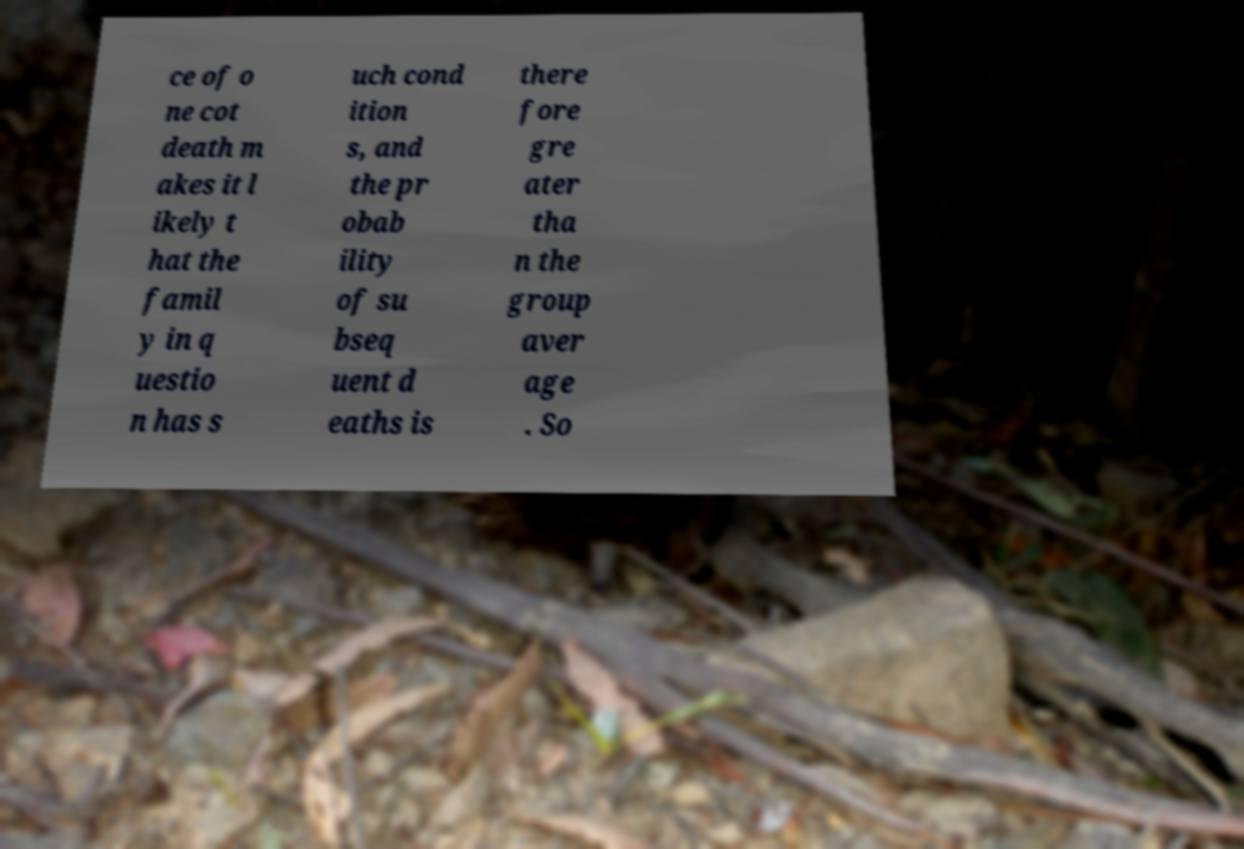There's text embedded in this image that I need extracted. Can you transcribe it verbatim? ce of o ne cot death m akes it l ikely t hat the famil y in q uestio n has s uch cond ition s, and the pr obab ility of su bseq uent d eaths is there fore gre ater tha n the group aver age . So 